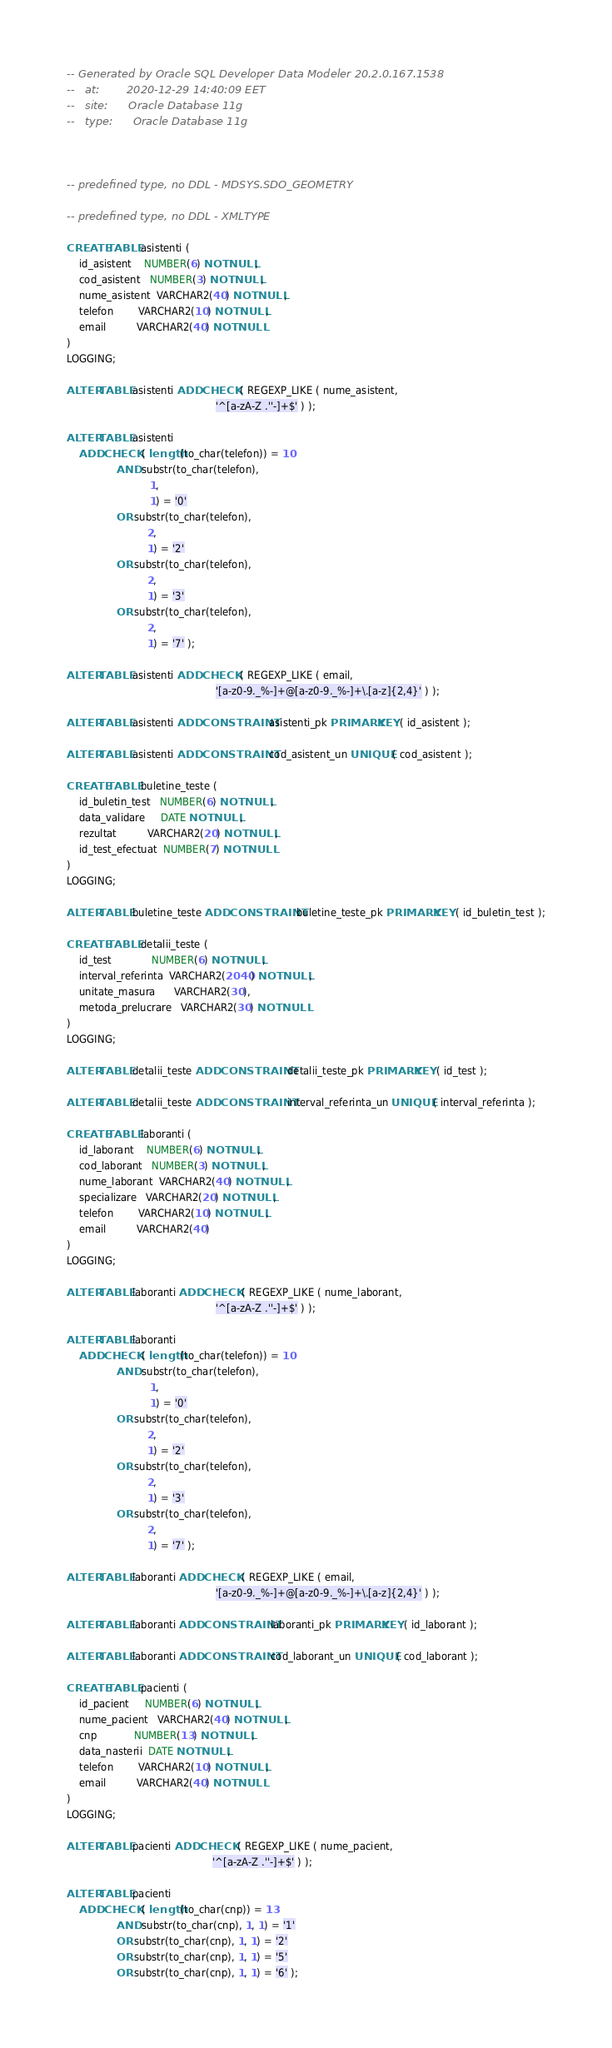Convert code to text. <code><loc_0><loc_0><loc_500><loc_500><_SQL_>-- Generated by Oracle SQL Developer Data Modeler 20.2.0.167.1538
--   at:        2020-12-29 14:40:09 EET
--   site:      Oracle Database 11g
--   type:      Oracle Database 11g



-- predefined type, no DDL - MDSYS.SDO_GEOMETRY

-- predefined type, no DDL - XMLTYPE

CREATE TABLE asistenti (
    id_asistent    NUMBER(6) NOT NULL,
    cod_asistent   NUMBER(3) NOT NULL,
    nume_asistent  VARCHAR2(40) NOT NULL,
    telefon        VARCHAR2(10) NOT NULL,
    email          VARCHAR2(40) NOT NULL
)
LOGGING;

ALTER TABLE asistenti ADD CHECK ( REGEXP_LIKE ( nume_asistent,
                                                '^[a-zA-Z .''-]+$' ) );

ALTER TABLE asistenti
    ADD CHECK ( length(to_char(telefon)) = 10
                AND substr(to_char(telefon),
                           1,
                           1) = '0'
                OR substr(to_char(telefon),
                          2,
                          1) = '2'
                OR substr(to_char(telefon),
                          2,
                          1) = '3'
                OR substr(to_char(telefon),
                          2,
                          1) = '7' );

ALTER TABLE asistenti ADD CHECK ( REGEXP_LIKE ( email,
                                                '[a-z0-9._%-]+@[a-z0-9._%-]+\.[a-z]{2,4}' ) );

ALTER TABLE asistenti ADD CONSTRAINT asistenti_pk PRIMARY KEY ( id_asistent );

ALTER TABLE asistenti ADD CONSTRAINT cod_asistent_un UNIQUE ( cod_asistent );

CREATE TABLE buletine_teste (
    id_buletin_test   NUMBER(6) NOT NULL,
    data_validare     DATE NOT NULL,
    rezultat          VARCHAR2(20) NOT NULL,
    id_test_efectuat  NUMBER(7) NOT NULL
)
LOGGING;

ALTER TABLE buletine_teste ADD CONSTRAINT buletine_teste_pk PRIMARY KEY ( id_buletin_test );

CREATE TABLE detalii_teste (
    id_test             NUMBER(6) NOT NULL,
    interval_referinta  VARCHAR2(2040) NOT NULL,
    unitate_masura      VARCHAR2(30),
    metoda_prelucrare   VARCHAR2(30) NOT NULL
)
LOGGING;

ALTER TABLE detalii_teste ADD CONSTRAINT detalii_teste_pk PRIMARY KEY ( id_test );

ALTER TABLE detalii_teste ADD CONSTRAINT interval_referinta_un UNIQUE ( interval_referinta );

CREATE TABLE laboranti (
    id_laborant    NUMBER(6) NOT NULL,
    cod_laborant   NUMBER(3) NOT NULL,
    nume_laborant  VARCHAR2(40) NOT NULL,
    specializare   VARCHAR2(20) NOT NULL,
    telefon        VARCHAR2(10) NOT NULL,
    email          VARCHAR2(40)
)
LOGGING;

ALTER TABLE laboranti ADD CHECK ( REGEXP_LIKE ( nume_laborant,
                                                '^[a-zA-Z .''-]+$' ) );

ALTER TABLE laboranti
    ADD CHECK ( length(to_char(telefon)) = 10
                AND substr(to_char(telefon),
                           1,
                           1) = '0'
                OR substr(to_char(telefon),
                          2,
                          1) = '2'
                OR substr(to_char(telefon),
                          2,
                          1) = '3'
                OR substr(to_char(telefon),
                          2,
                          1) = '7' );

ALTER TABLE laboranti ADD CHECK ( REGEXP_LIKE ( email,
                                                '[a-z0-9._%-]+@[a-z0-9._%-]+\.[a-z]{2,4}' ) );

ALTER TABLE laboranti ADD CONSTRAINT laboranti_pk PRIMARY KEY ( id_laborant );

ALTER TABLE laboranti ADD CONSTRAINT cod_laborant_un UNIQUE ( cod_laborant );

CREATE TABLE pacienti (
    id_pacient     NUMBER(6) NOT NULL,
    nume_pacient   VARCHAR2(40) NOT NULL,
    cnp            NUMBER(13) NOT NULL,
    data_nasterii  DATE NOT NULL,
    telefon        VARCHAR2(10) NOT NULL,
    email          VARCHAR2(40) NOT NULL
)
LOGGING;

ALTER TABLE pacienti ADD CHECK ( REGEXP_LIKE ( nume_pacient,
                                               '^[a-zA-Z .''-]+$' ) );

ALTER TABLE pacienti
    ADD CHECK ( length(to_char(cnp)) = 13
                AND substr(to_char(cnp), 1, 1) = '1'
                OR substr(to_char(cnp), 1, 1) = '2'
                OR substr(to_char(cnp), 1, 1) = '5'
                OR substr(to_char(cnp), 1, 1) = '6' );
</code> 